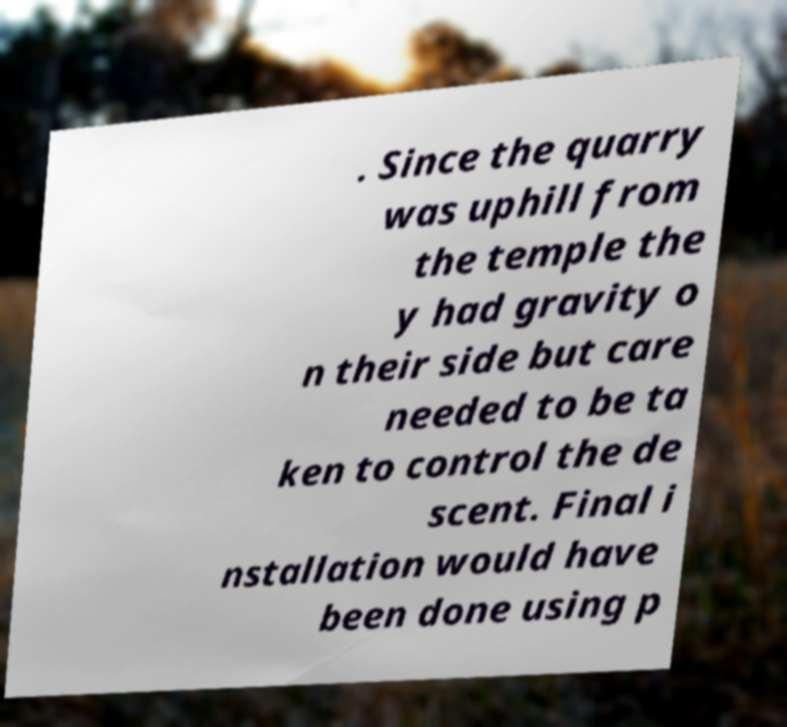Could you extract and type out the text from this image? . Since the quarry was uphill from the temple the y had gravity o n their side but care needed to be ta ken to control the de scent. Final i nstallation would have been done using p 